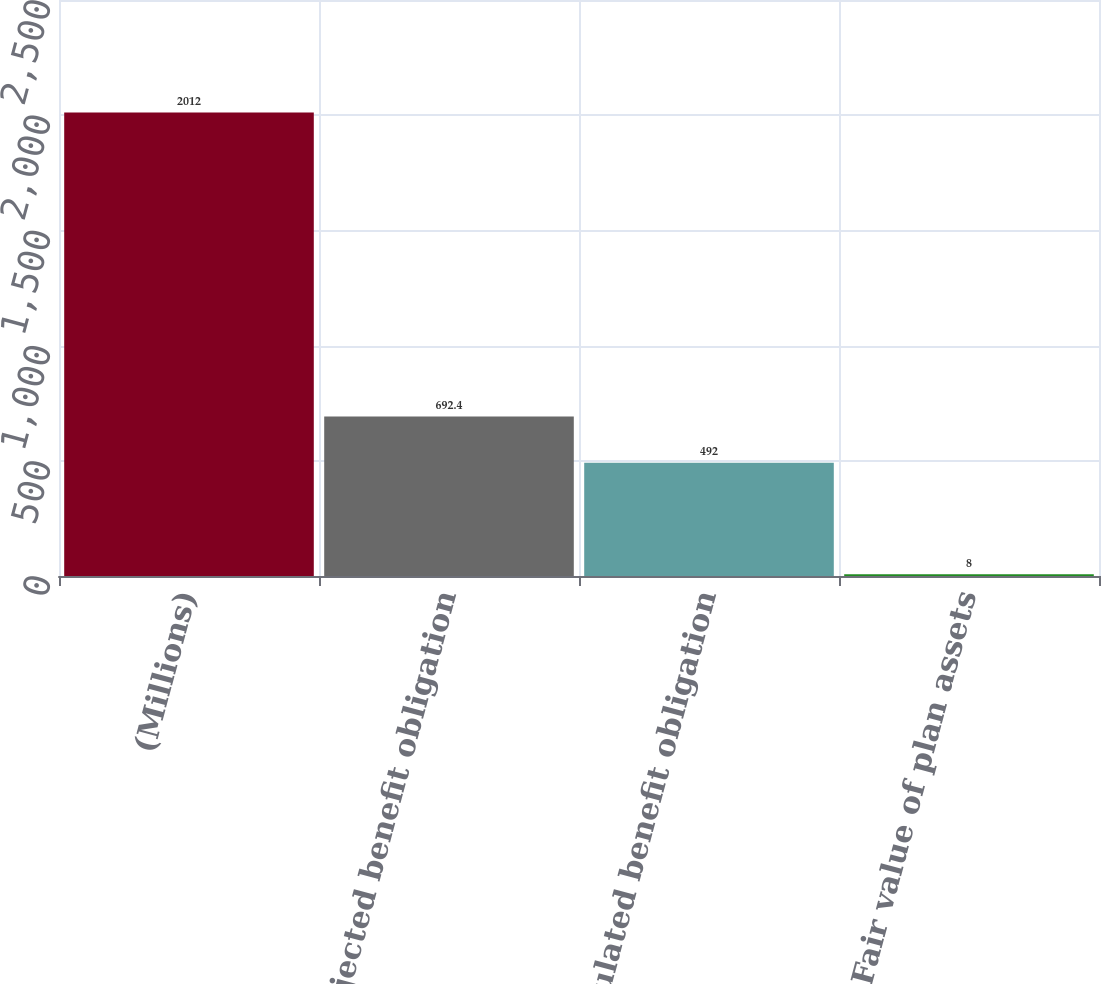Convert chart. <chart><loc_0><loc_0><loc_500><loc_500><bar_chart><fcel>(Millions)<fcel>Projected benefit obligation<fcel>Accumulated benefit obligation<fcel>Fair value of plan assets<nl><fcel>2012<fcel>692.4<fcel>492<fcel>8<nl></chart> 